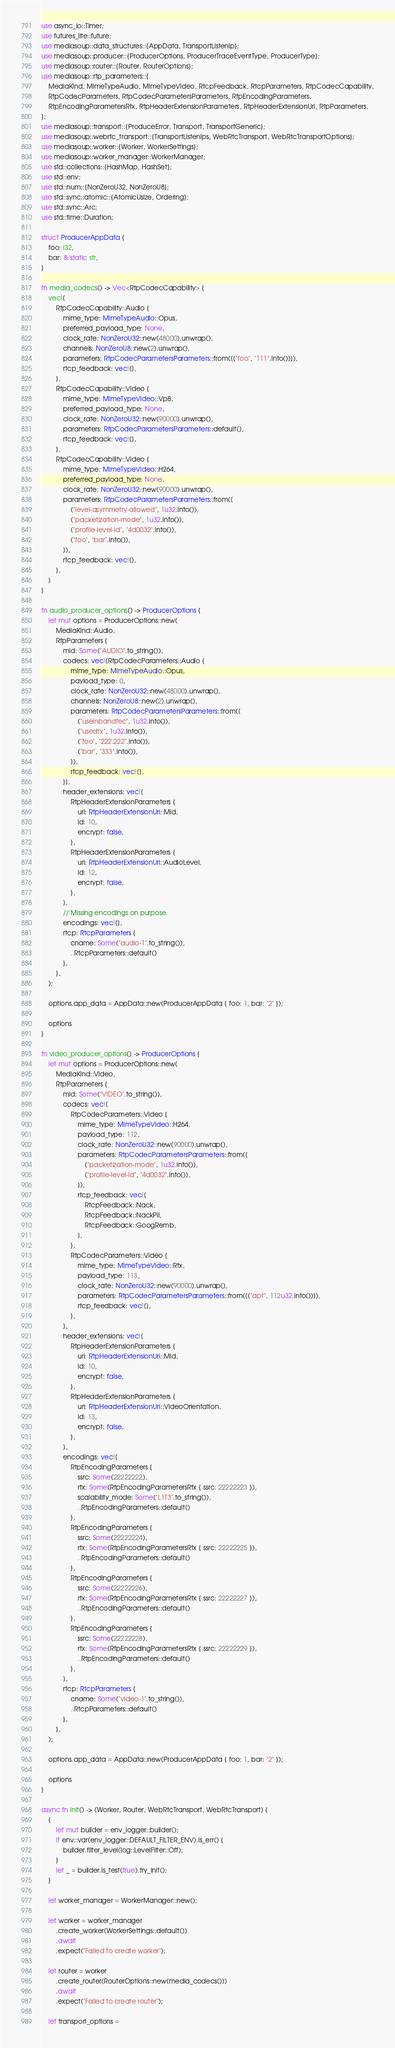Convert code to text. <code><loc_0><loc_0><loc_500><loc_500><_Rust_>use async_io::Timer;
use futures_lite::future;
use mediasoup::data_structures::{AppData, TransportListenIp};
use mediasoup::producer::{ProducerOptions, ProducerTraceEventType, ProducerType};
use mediasoup::router::{Router, RouterOptions};
use mediasoup::rtp_parameters::{
    MediaKind, MimeTypeAudio, MimeTypeVideo, RtcpFeedback, RtcpParameters, RtpCodecCapability,
    RtpCodecParameters, RtpCodecParametersParameters, RtpEncodingParameters,
    RtpEncodingParametersRtx, RtpHeaderExtensionParameters, RtpHeaderExtensionUri, RtpParameters,
};
use mediasoup::transport::{ProduceError, Transport, TransportGeneric};
use mediasoup::webrtc_transport::{TransportListenIps, WebRtcTransport, WebRtcTransportOptions};
use mediasoup::worker::{Worker, WorkerSettings};
use mediasoup::worker_manager::WorkerManager;
use std::collections::{HashMap, HashSet};
use std::env;
use std::num::{NonZeroU32, NonZeroU8};
use std::sync::atomic::{AtomicUsize, Ordering};
use std::sync::Arc;
use std::time::Duration;

struct ProducerAppData {
    foo: i32,
    bar: &'static str,
}

fn media_codecs() -> Vec<RtpCodecCapability> {
    vec![
        RtpCodecCapability::Audio {
            mime_type: MimeTypeAudio::Opus,
            preferred_payload_type: None,
            clock_rate: NonZeroU32::new(48000).unwrap(),
            channels: NonZeroU8::new(2).unwrap(),
            parameters: RtpCodecParametersParameters::from([("foo", "111".into())]),
            rtcp_feedback: vec![],
        },
        RtpCodecCapability::Video {
            mime_type: MimeTypeVideo::Vp8,
            preferred_payload_type: None,
            clock_rate: NonZeroU32::new(90000).unwrap(),
            parameters: RtpCodecParametersParameters::default(),
            rtcp_feedback: vec![],
        },
        RtpCodecCapability::Video {
            mime_type: MimeTypeVideo::H264,
            preferred_payload_type: None,
            clock_rate: NonZeroU32::new(90000).unwrap(),
            parameters: RtpCodecParametersParameters::from([
                ("level-asymmetry-allowed", 1u32.into()),
                ("packetization-mode", 1u32.into()),
                ("profile-level-id", "4d0032".into()),
                ("foo", "bar".into()),
            ]),
            rtcp_feedback: vec![],
        },
    ]
}

fn audio_producer_options() -> ProducerOptions {
    let mut options = ProducerOptions::new(
        MediaKind::Audio,
        RtpParameters {
            mid: Some("AUDIO".to_string()),
            codecs: vec![RtpCodecParameters::Audio {
                mime_type: MimeTypeAudio::Opus,
                payload_type: 0,
                clock_rate: NonZeroU32::new(48000).unwrap(),
                channels: NonZeroU8::new(2).unwrap(),
                parameters: RtpCodecParametersParameters::from([
                    ("useinbandfec", 1u32.into()),
                    ("usedtx", 1u32.into()),
                    ("foo", "222.222".into()),
                    ("bar", "333".into()),
                ]),
                rtcp_feedback: vec![],
            }],
            header_extensions: vec![
                RtpHeaderExtensionParameters {
                    uri: RtpHeaderExtensionUri::Mid,
                    id: 10,
                    encrypt: false,
                },
                RtpHeaderExtensionParameters {
                    uri: RtpHeaderExtensionUri::AudioLevel,
                    id: 12,
                    encrypt: false,
                },
            ],
            // Missing encodings on purpose.
            encodings: vec![],
            rtcp: RtcpParameters {
                cname: Some("audio-1".to_string()),
                ..RtcpParameters::default()
            },
        },
    );

    options.app_data = AppData::new(ProducerAppData { foo: 1, bar: "2" });

    options
}

fn video_producer_options() -> ProducerOptions {
    let mut options = ProducerOptions::new(
        MediaKind::Video,
        RtpParameters {
            mid: Some("VIDEO".to_string()),
            codecs: vec![
                RtpCodecParameters::Video {
                    mime_type: MimeTypeVideo::H264,
                    payload_type: 112,
                    clock_rate: NonZeroU32::new(90000).unwrap(),
                    parameters: RtpCodecParametersParameters::from([
                        ("packetization-mode", 1u32.into()),
                        ("profile-level-id", "4d0032".into()),
                    ]),
                    rtcp_feedback: vec![
                        RtcpFeedback::Nack,
                        RtcpFeedback::NackPli,
                        RtcpFeedback::GoogRemb,
                    ],
                },
                RtpCodecParameters::Video {
                    mime_type: MimeTypeVideo::Rtx,
                    payload_type: 113,
                    clock_rate: NonZeroU32::new(90000).unwrap(),
                    parameters: RtpCodecParametersParameters::from([("apt", 112u32.into())]),
                    rtcp_feedback: vec![],
                },
            ],
            header_extensions: vec![
                RtpHeaderExtensionParameters {
                    uri: RtpHeaderExtensionUri::Mid,
                    id: 10,
                    encrypt: false,
                },
                RtpHeaderExtensionParameters {
                    uri: RtpHeaderExtensionUri::VideoOrientation,
                    id: 13,
                    encrypt: false,
                },
            ],
            encodings: vec![
                RtpEncodingParameters {
                    ssrc: Some(22222222),
                    rtx: Some(RtpEncodingParametersRtx { ssrc: 22222223 }),
                    scalability_mode: Some("L1T3".to_string()),
                    ..RtpEncodingParameters::default()
                },
                RtpEncodingParameters {
                    ssrc: Some(22222224),
                    rtx: Some(RtpEncodingParametersRtx { ssrc: 22222225 }),
                    ..RtpEncodingParameters::default()
                },
                RtpEncodingParameters {
                    ssrc: Some(22222226),
                    rtx: Some(RtpEncodingParametersRtx { ssrc: 22222227 }),
                    ..RtpEncodingParameters::default()
                },
                RtpEncodingParameters {
                    ssrc: Some(22222228),
                    rtx: Some(RtpEncodingParametersRtx { ssrc: 22222229 }),
                    ..RtpEncodingParameters::default()
                },
            ],
            rtcp: RtcpParameters {
                cname: Some("video-1".to_string()),
                ..RtcpParameters::default()
            },
        },
    );

    options.app_data = AppData::new(ProducerAppData { foo: 1, bar: "2" });

    options
}

async fn init() -> (Worker, Router, WebRtcTransport, WebRtcTransport) {
    {
        let mut builder = env_logger::builder();
        if env::var(env_logger::DEFAULT_FILTER_ENV).is_err() {
            builder.filter_level(log::LevelFilter::Off);
        }
        let _ = builder.is_test(true).try_init();
    }

    let worker_manager = WorkerManager::new();

    let worker = worker_manager
        .create_worker(WorkerSettings::default())
        .await
        .expect("Failed to create worker");

    let router = worker
        .create_router(RouterOptions::new(media_codecs()))
        .await
        .expect("Failed to create router");

    let transport_options =</code> 